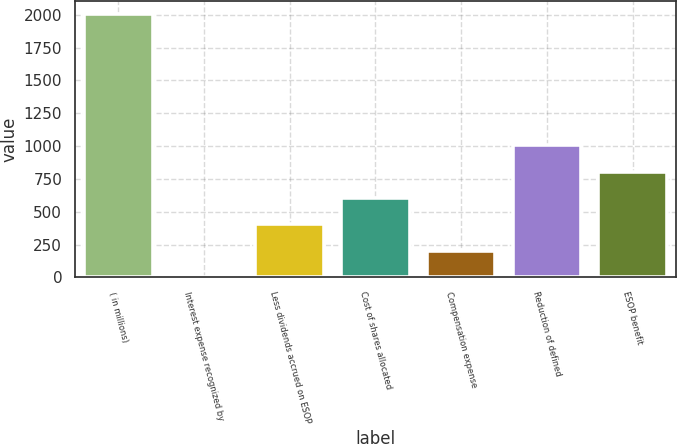<chart> <loc_0><loc_0><loc_500><loc_500><bar_chart><fcel>( in millions)<fcel>Interest expense recognized by<fcel>Less dividends accrued on ESOP<fcel>Cost of shares allocated<fcel>Compensation expense<fcel>Reduction of defined<fcel>ESOP benefit<nl><fcel>2006<fcel>4<fcel>404.4<fcel>604.6<fcel>204.2<fcel>1005<fcel>804.8<nl></chart> 